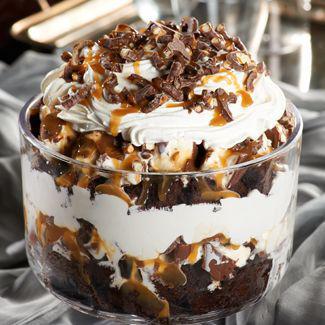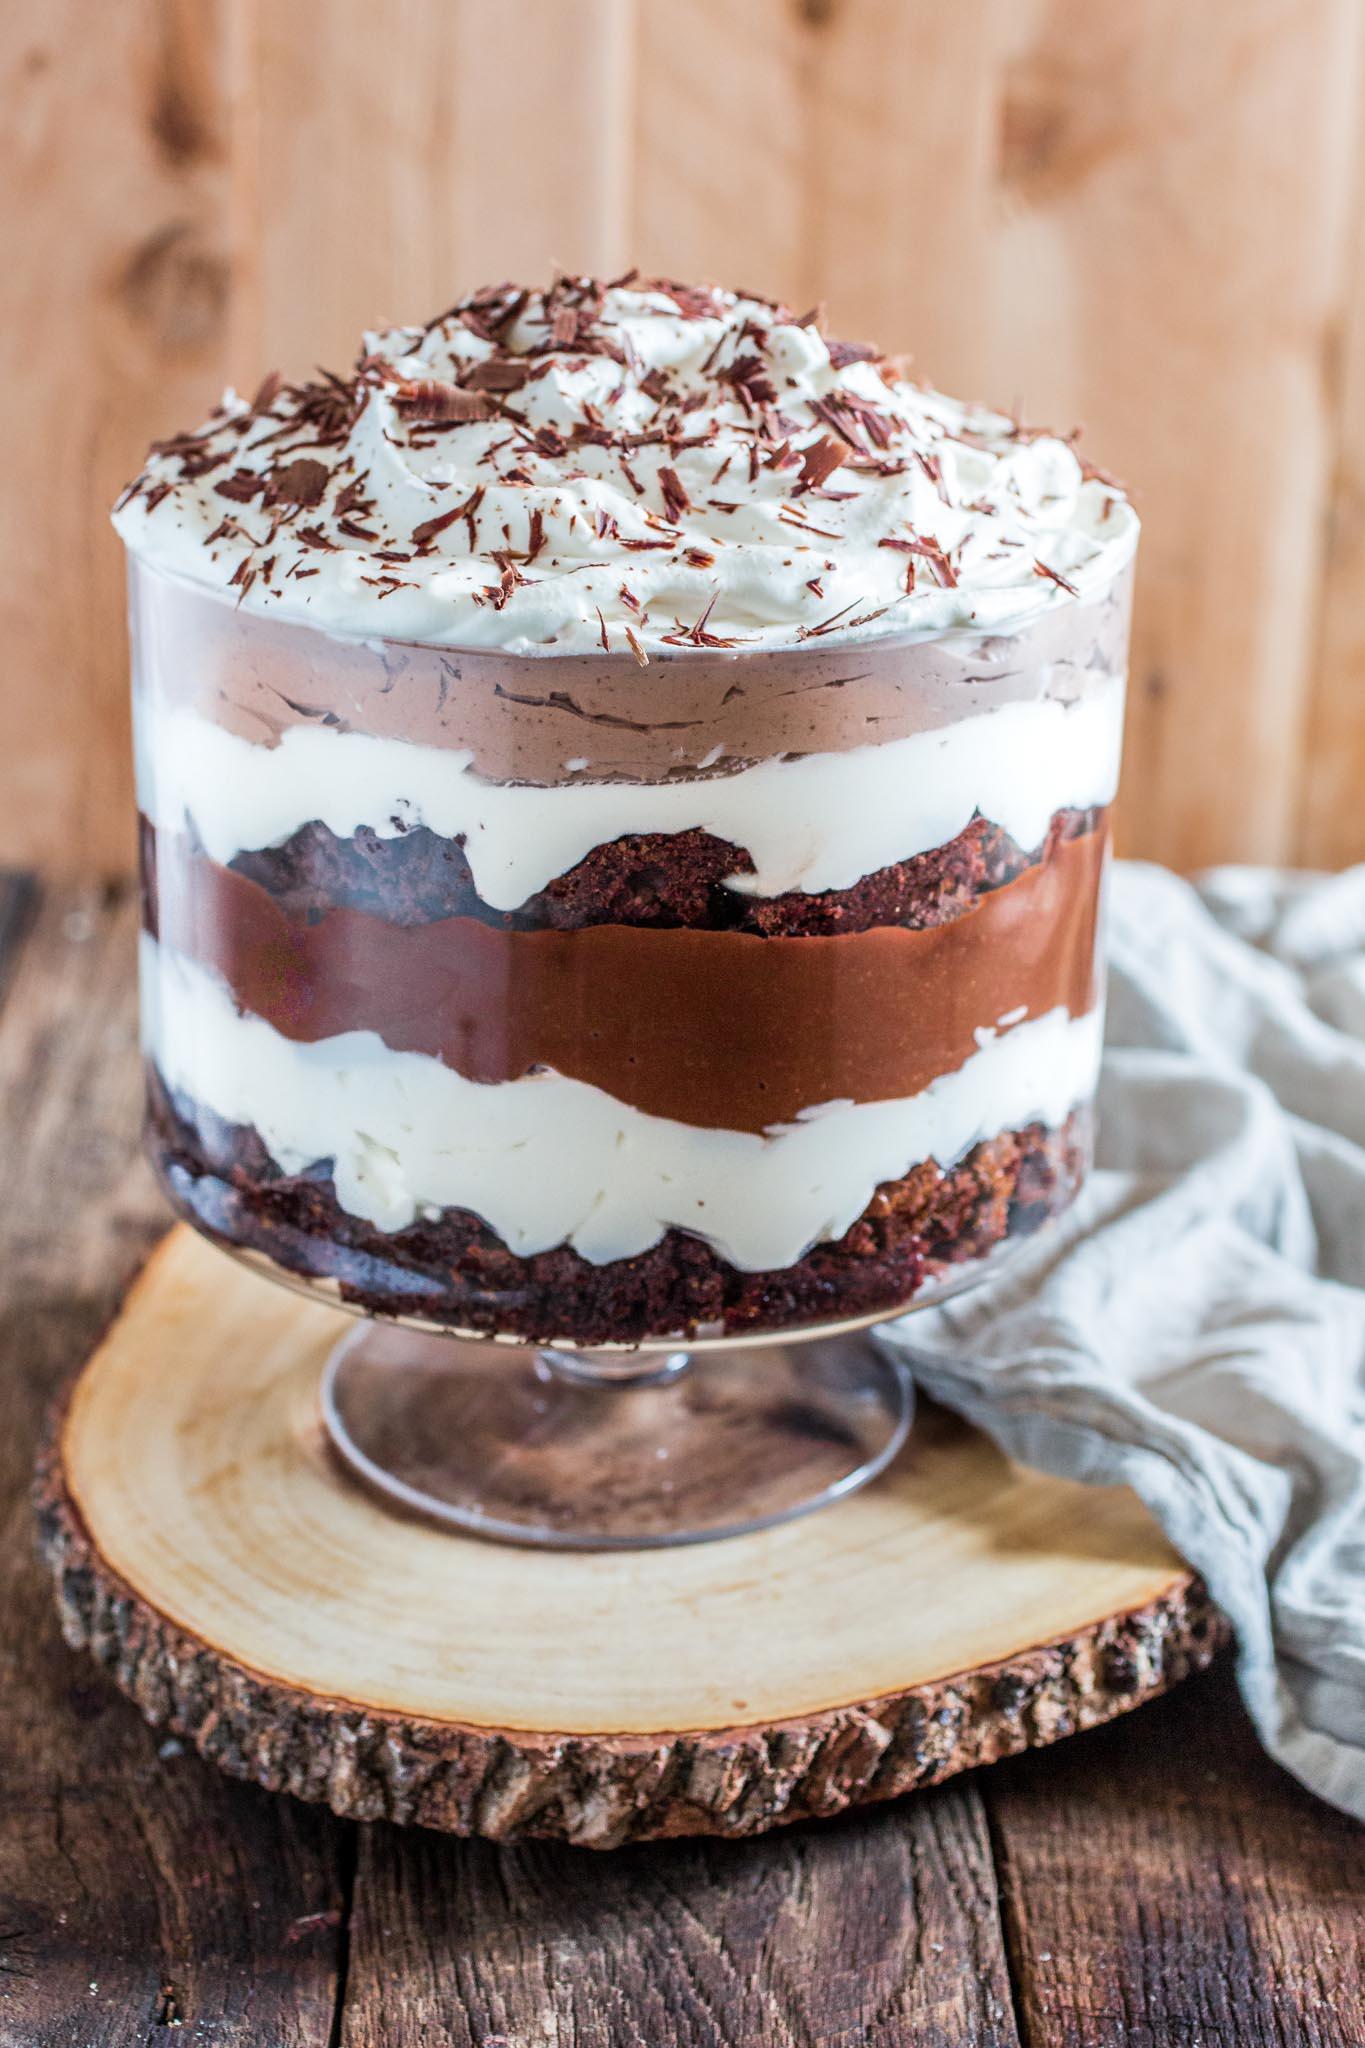The first image is the image on the left, the second image is the image on the right. Considering the images on both sides, is "An image shows one large dessert that is drizzled with caramel over the cream on top." valid? Answer yes or no. Yes. The first image is the image on the left, the second image is the image on the right. Assess this claim about the two images: "The dessert in the image on the right is sitting on a wooden surface.". Correct or not? Answer yes or no. Yes. 